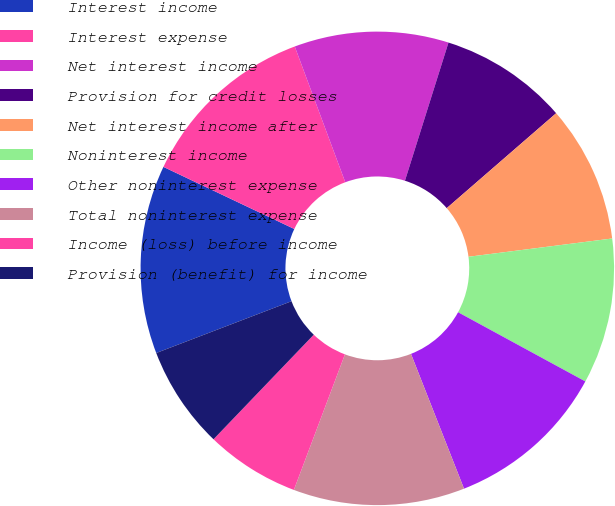Convert chart to OTSL. <chart><loc_0><loc_0><loc_500><loc_500><pie_chart><fcel>Interest income<fcel>Interest expense<fcel>Net interest income<fcel>Provision for credit losses<fcel>Net interest income after<fcel>Noninterest income<fcel>Other noninterest expense<fcel>Total noninterest expense<fcel>Income (loss) before income<fcel>Provision (benefit) for income<nl><fcel>12.87%<fcel>12.28%<fcel>10.53%<fcel>8.77%<fcel>9.36%<fcel>9.94%<fcel>11.11%<fcel>11.7%<fcel>6.43%<fcel>7.02%<nl></chart> 